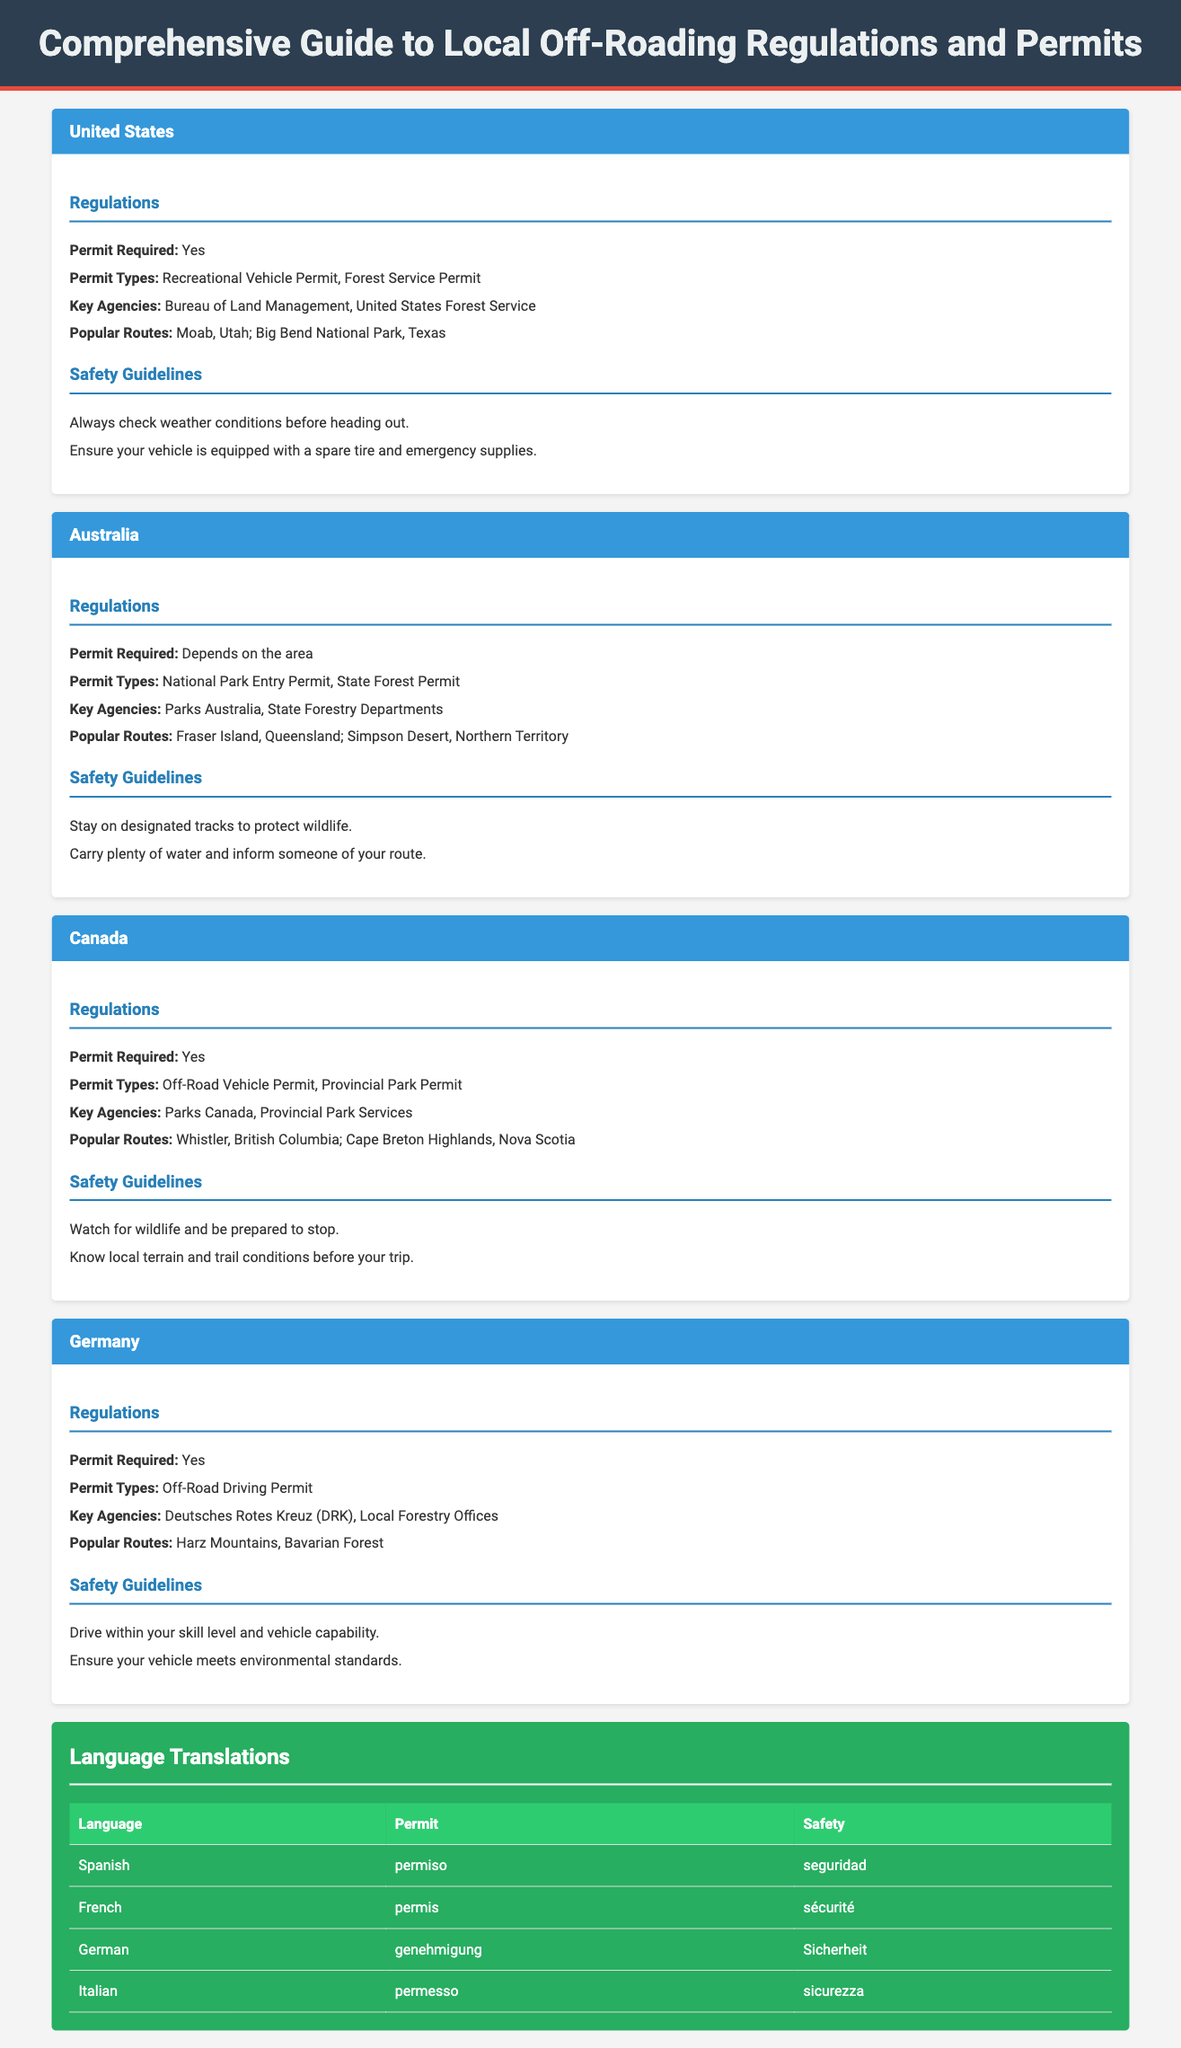what permit is required in the United States? The document states that a Recreational Vehicle Permit and Forest Service Permit are required in the United States.
Answer: Recreational Vehicle Permit what is a popular off-roading route in Australia? The document lists Fraser Island and Simpson Desert as popular routes in Australia.
Answer: Fraser Island how many key agencies are listed for Canada? There are two key agencies mentioned for Canada: Parks Canada and Provincial Park Services.
Answer: 2 what safety guideline is mentioned for off-roading in Germany? One of the safety guidelines specifies driving within your skill level and vehicle capability.
Answer: Drive within your skill level which country requires a permit for off-roading? The document states that a permit is required in several countries, including the United States, Canada, and Germany.
Answer: United States what is the German word for "permit"? The document provides "genehmigung" as the translation for "permit" in German.
Answer: genehmigung how many regulations are outlined for Australia? The regulations section for Australia includes four points listed under regulations.
Answer: 4 what agency is mentioned for the United States? The Bureau of Land Management is one of the key agencies mentioned for the United States.
Answer: Bureau of Land Management what is a common safety recommendation for off-roading? A safety guideline advises carrying plenty of water and informing someone of your route.
Answer: Carry plenty of water 